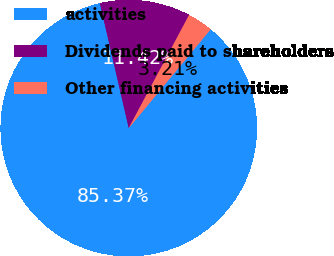<chart> <loc_0><loc_0><loc_500><loc_500><pie_chart><fcel>activities<fcel>Dividends paid to shareholders<fcel>Other financing activities<nl><fcel>85.37%<fcel>11.42%<fcel>3.21%<nl></chart> 